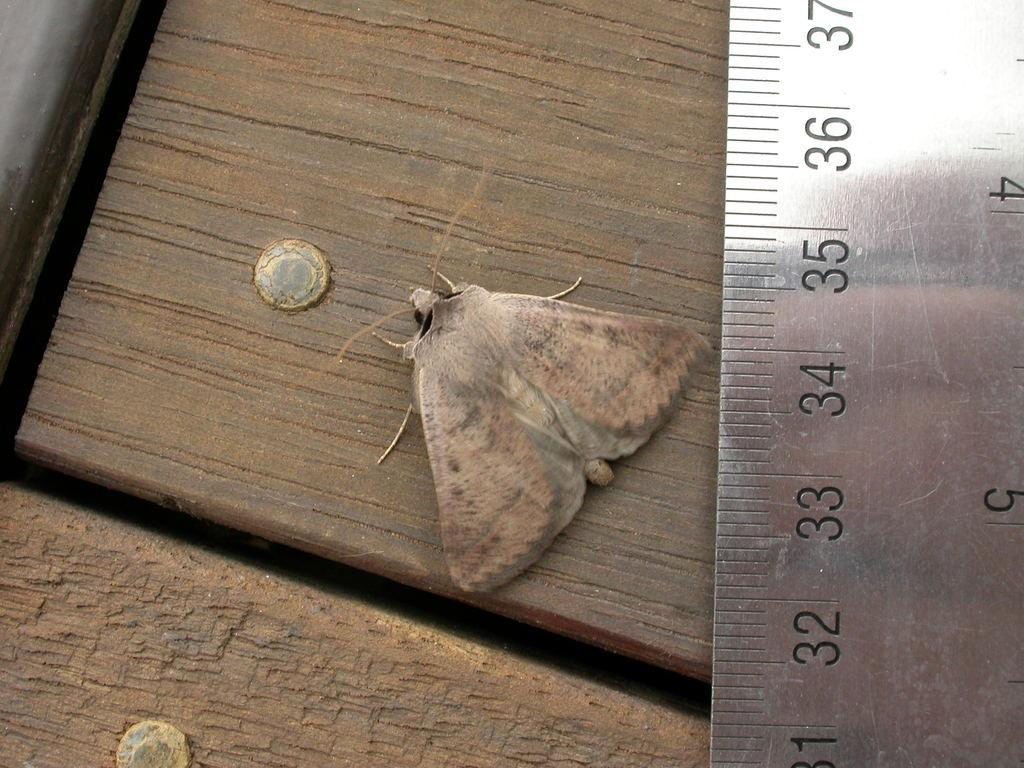<image>
Share a concise interpretation of the image provided. Ruler that goes up to 37 measuring a moth. 